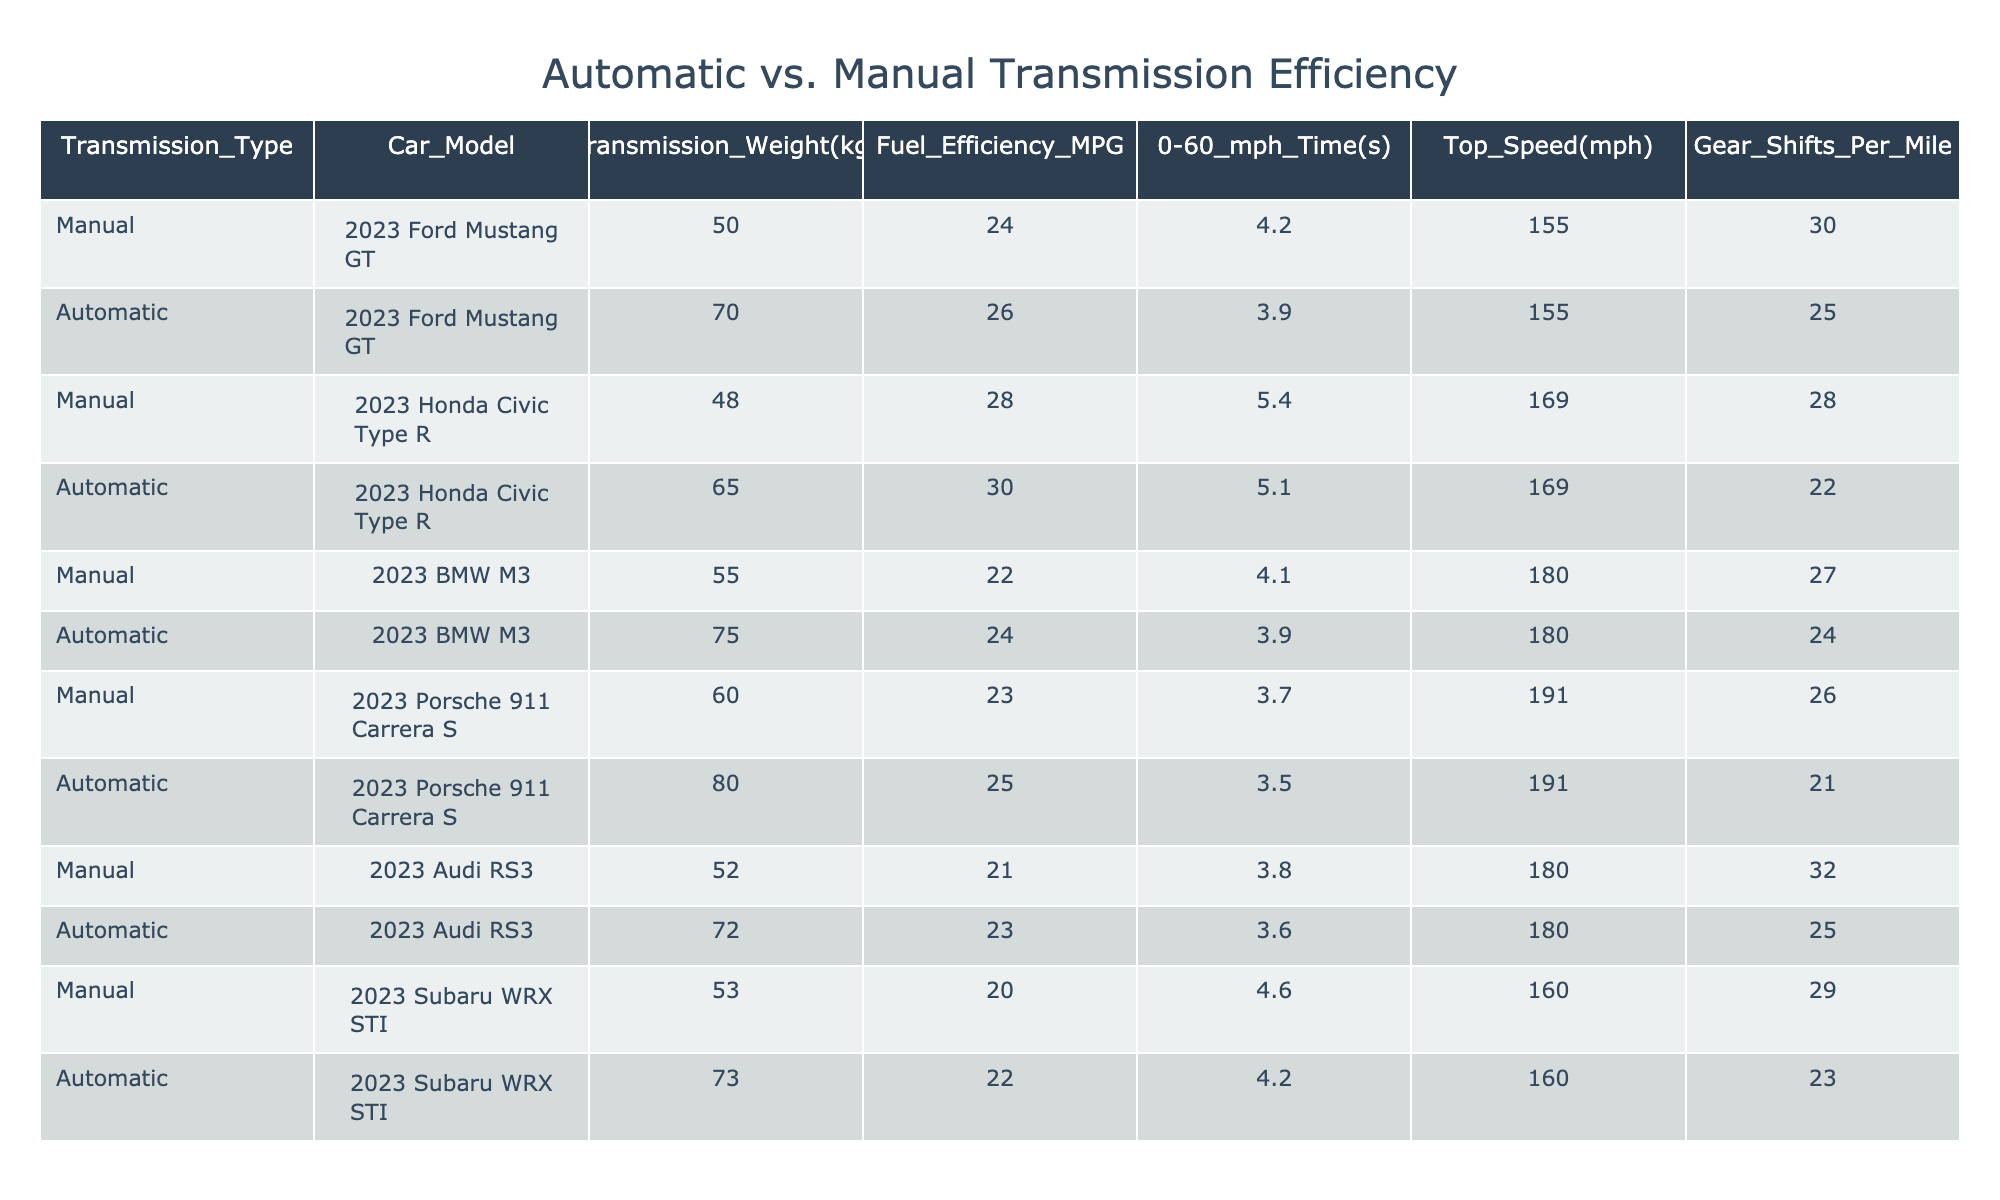What is the fuel efficiency (MPG) of the 2023 Honda Civic Type R with a manual transmission? According to the table, under the row for the 2023 Honda Civic Type R with a manual transmission, the fuel efficiency is listed as 28 MPG.
Answer: 28 MPG Which car model has the highest top speed? By examining the top speed column for each car model, the 2023 Porsche 911 Carrera S shows the highest top speed of 191 mph.
Answer: 191 mph What is the difference in transmission weight between the automatic and manual transmission of the 2023 Audi RS3? The weights for the 2023 Audi RS3 are 72 kg for the automatic transmission and 52 kg for the manual transmission. The difference is calculated as 72 kg - 52 kg = 20 kg.
Answer: 20 kg Is the fuel efficiency of the automatic 2023 Ford Mustang GT higher than that of the manual 2023 Ford Mustang GT? The fuel efficiency of the automatic 2023 Ford Mustang GT is 26 MPG and for the manual, it is 24 MPG. Since 26 MPG is greater than 24 MPG, the statement is true.
Answer: Yes What is the average 0-60 mph time for all manual cars listed in the table? The 0-60 mph times for manual cars are 4.2 s (Mustang GT), 5.4 s (Civic Type R), 4.1 s (BMW M3), 3.7 s (Porsche 911 Carrera S), 3.8 s (Audi RS3), and 4.6 s (Subaru WRX STI). Adding these times gives 4.2 + 5.4 + 4.1 + 3.7 + 3.8 + 4.6 = 25.8 s. The average is 25.8 s / 6 = 4.3 s.
Answer: 4.3 s Does the 2023 Subaru WRX STI with a manual transmission have more gear shifts per mile than the automatic version? The manual version of the 2023 Subaru WRX STI has 29 gear shifts per mile, while the automatic version has 23. Since 29 is greater than 23, the statement is true.
Answer: Yes 